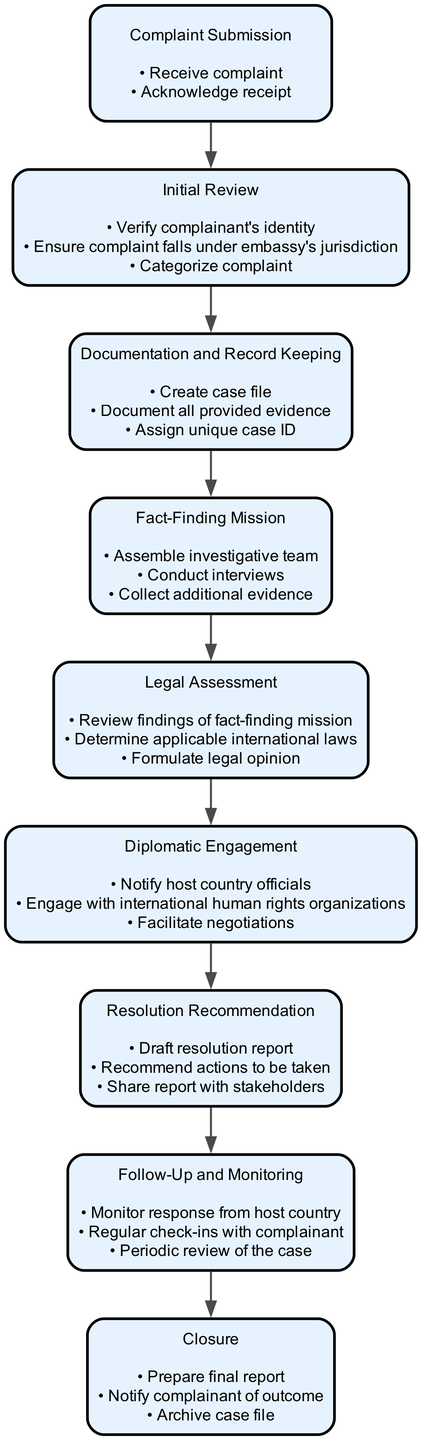What is the first step in the workflow? The first step in the workflow as per the diagram is "Complaint Submission," which involves receiving and acknowledging the complaint.
Answer: Complaint Submission How many actions are involved in the "Initial Review" step? The "Initial Review" step consists of three actions: verify complainant's identity, ensure complaint falls under embassy's jurisdiction, and categorize complaint.
Answer: 3 What is the final step of the workflow? The final step of the workflow is "Closure," which involves preparing a final report, notifying the complainant of the outcome, and archiving the case file.
Answer: Closure Which step comes after "Documentation and Record Keeping"? The step that comes after "Documentation and Record Keeping" is "Fact-Finding Mission." This indicates that after documentation, the next task is to conduct an investigation.
Answer: Fact-Finding Mission What actions are taken during the "Legal Assessment" phase? In the "Legal Assessment" phase, the actions taken include reviewing findings from the fact-finding mission, determining applicable international laws, and formulating a legal opinion.
Answer: Review findings, determine applicable international laws, formulate legal opinion What is the relationship between "Diplomatic Engagement" and "Resolution Recommendation"? "Diplomatic Engagement" precedes "Resolution Recommendation," indicating that after engaging with relevant entities, the next step is to develop proposed solutions based on the engagement findings.
Answer: "Diplomatic Engagement" precedes "Resolution Recommendation" How many total steps are there in the workflow? The diagram outlines a total of nine steps in the workflow for addressing human rights complaints submitted to the embassy.
Answer: 9 